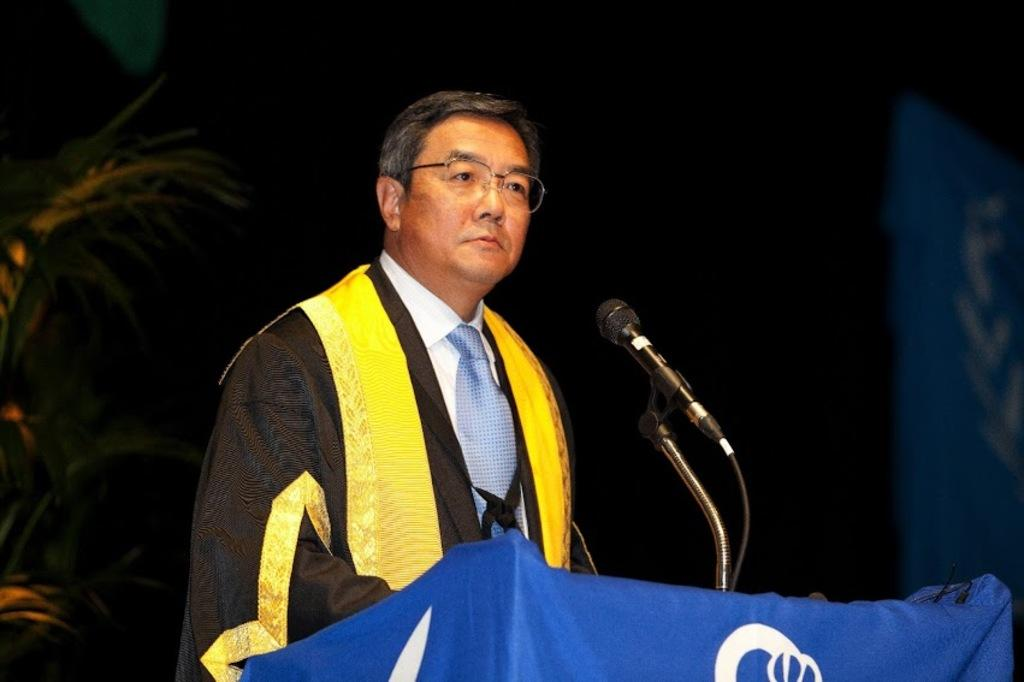Who is present in the image? There is a man in the image. What is the man doing in the image? The man is standing in the image. What object can be seen on the table in the image? There is a microphone on the table in the image. What type of spy equipment can be seen on the man in the image? There is no spy equipment visible on the man in the image. What part of the man's body is being observed in the image? There is no specific part of the man's body being observed in the image; the focus is on his standing position and the presence of a microphone on the table. 